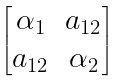Convert formula to latex. <formula><loc_0><loc_0><loc_500><loc_500>\begin{bmatrix} \alpha _ { 1 } & a _ { 1 2 } \\ a _ { 1 2 } & \alpha _ { 2 } \end{bmatrix}</formula> 